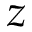Convert formula to latex. <formula><loc_0><loc_0><loc_500><loc_500>z</formula> 